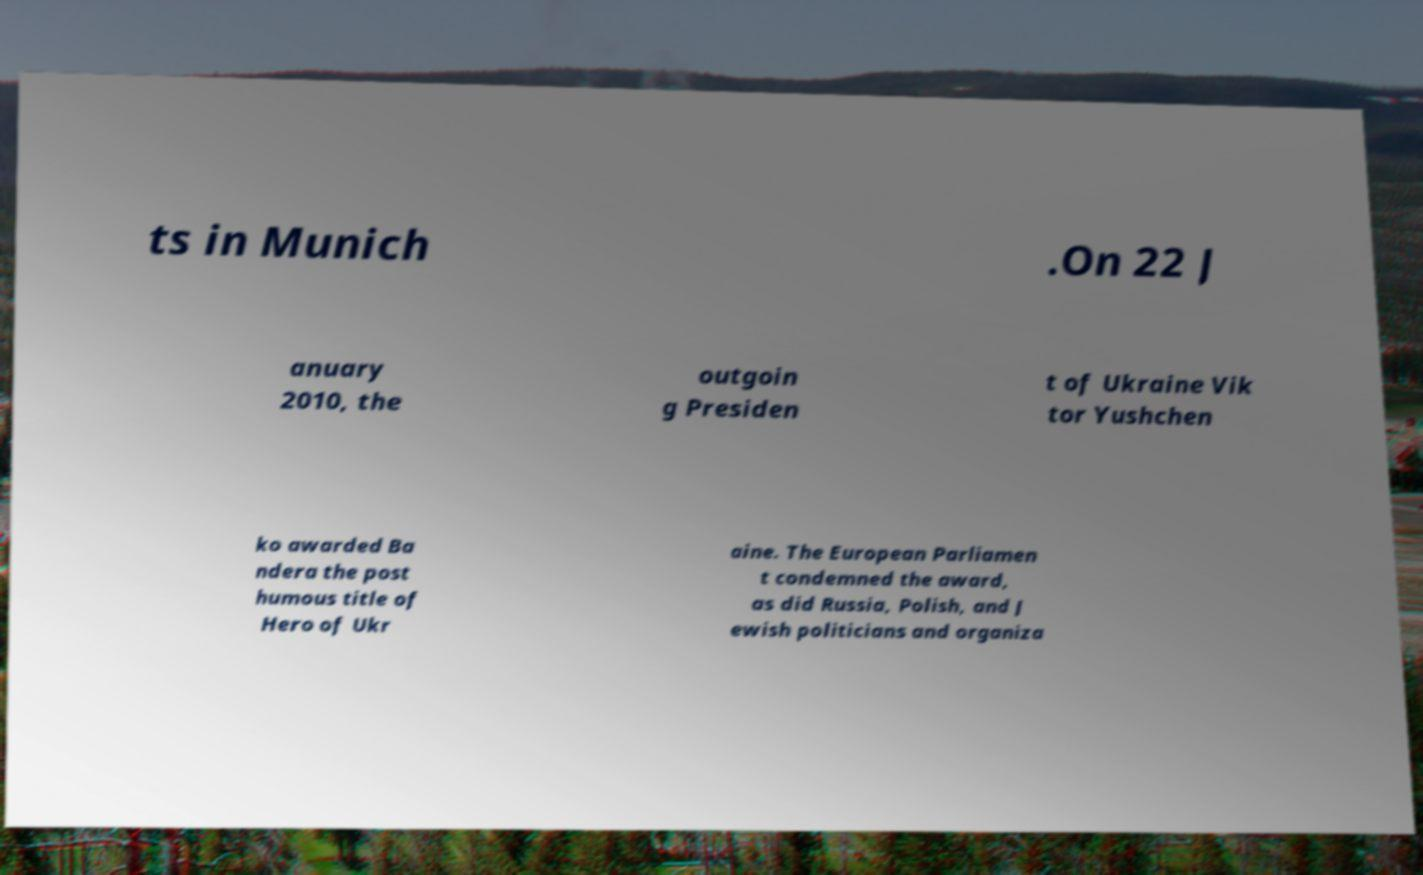There's text embedded in this image that I need extracted. Can you transcribe it verbatim? ts in Munich .On 22 J anuary 2010, the outgoin g Presiden t of Ukraine Vik tor Yushchen ko awarded Ba ndera the post humous title of Hero of Ukr aine. The European Parliamen t condemned the award, as did Russia, Polish, and J ewish politicians and organiza 